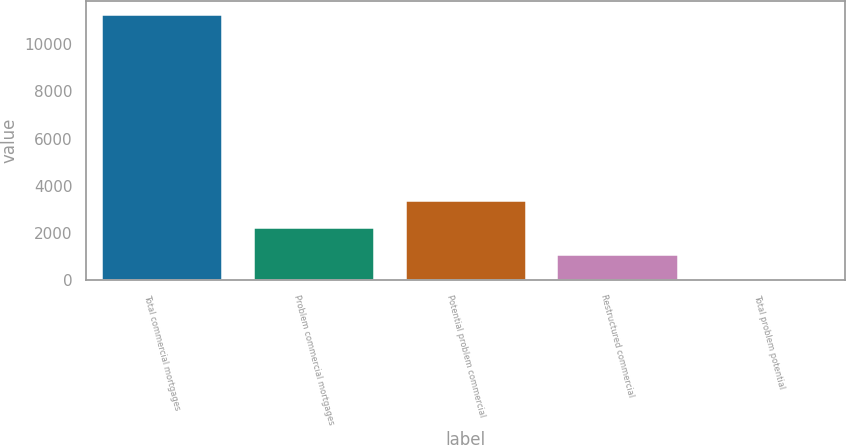Convert chart to OTSL. <chart><loc_0><loc_0><loc_500><loc_500><bar_chart><fcel>Total commercial mortgages<fcel>Problem commercial mortgages<fcel>Potential problem commercial<fcel>Restructured commercial<fcel>Total problem potential<nl><fcel>11279.3<fcel>2257.18<fcel>3384.95<fcel>1129.41<fcel>1.64<nl></chart> 